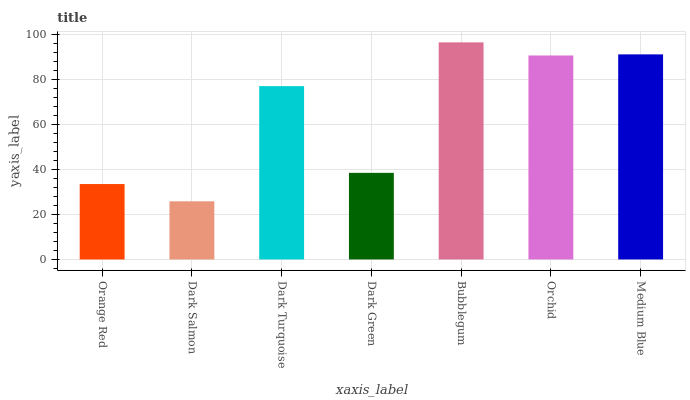Is Dark Salmon the minimum?
Answer yes or no. Yes. Is Bubblegum the maximum?
Answer yes or no. Yes. Is Dark Turquoise the minimum?
Answer yes or no. No. Is Dark Turquoise the maximum?
Answer yes or no. No. Is Dark Turquoise greater than Dark Salmon?
Answer yes or no. Yes. Is Dark Salmon less than Dark Turquoise?
Answer yes or no. Yes. Is Dark Salmon greater than Dark Turquoise?
Answer yes or no. No. Is Dark Turquoise less than Dark Salmon?
Answer yes or no. No. Is Dark Turquoise the high median?
Answer yes or no. Yes. Is Dark Turquoise the low median?
Answer yes or no. Yes. Is Medium Blue the high median?
Answer yes or no. No. Is Orchid the low median?
Answer yes or no. No. 